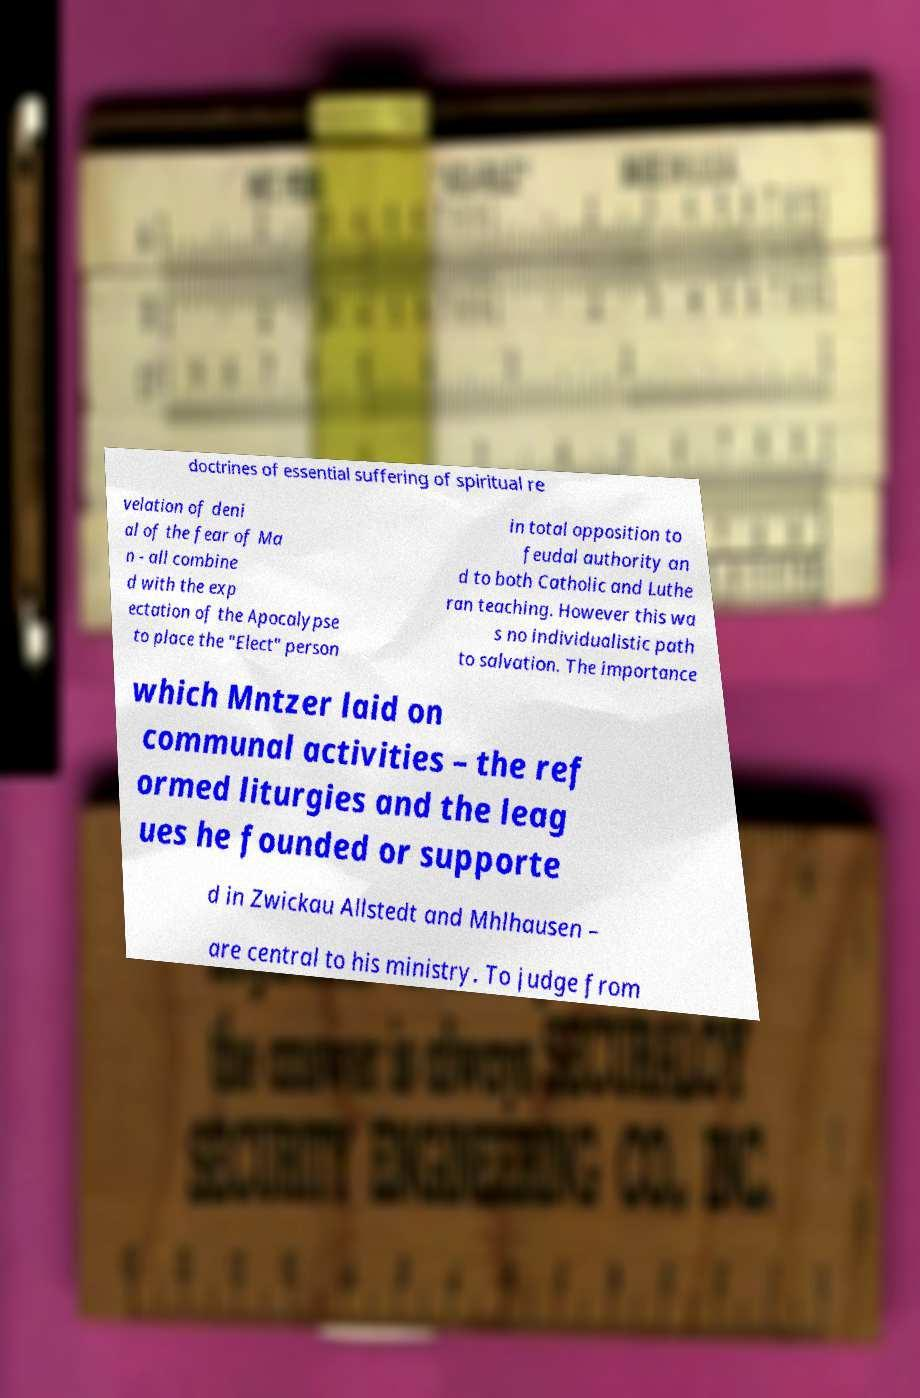For documentation purposes, I need the text within this image transcribed. Could you provide that? doctrines of essential suffering of spiritual re velation of deni al of the fear of Ma n - all combine d with the exp ectation of the Apocalypse to place the "Elect" person in total opposition to feudal authority an d to both Catholic and Luthe ran teaching. However this wa s no individualistic path to salvation. The importance which Mntzer laid on communal activities – the ref ormed liturgies and the leag ues he founded or supporte d in Zwickau Allstedt and Mhlhausen – are central to his ministry. To judge from 